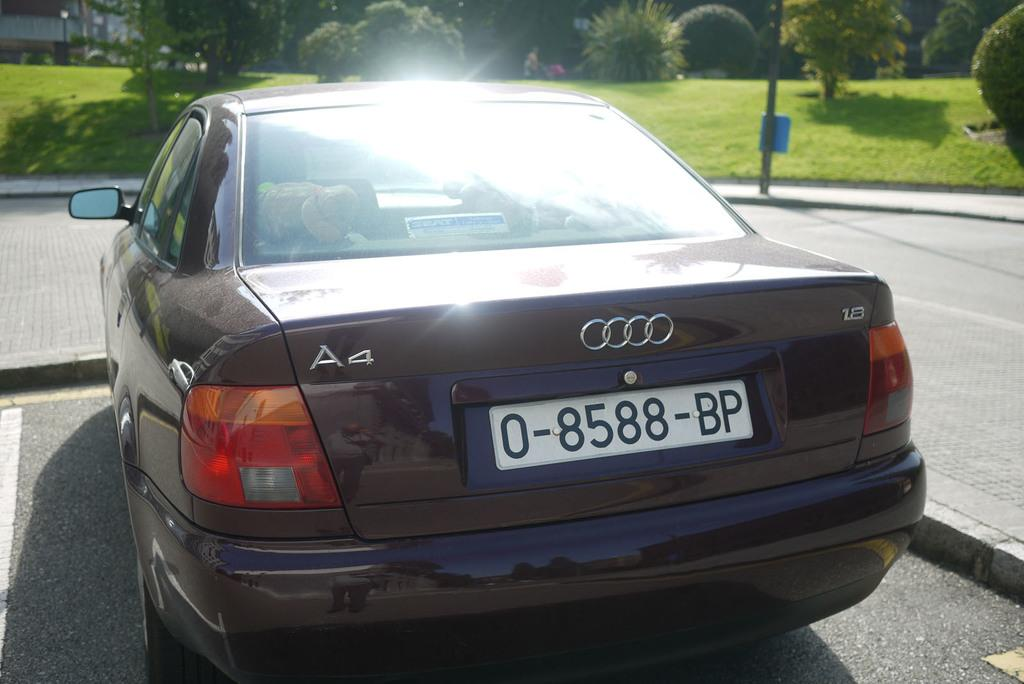<image>
Summarize the visual content of the image. A dark blue Mercedes with license plate number 0-8588-BP is parked in a parking lot. 